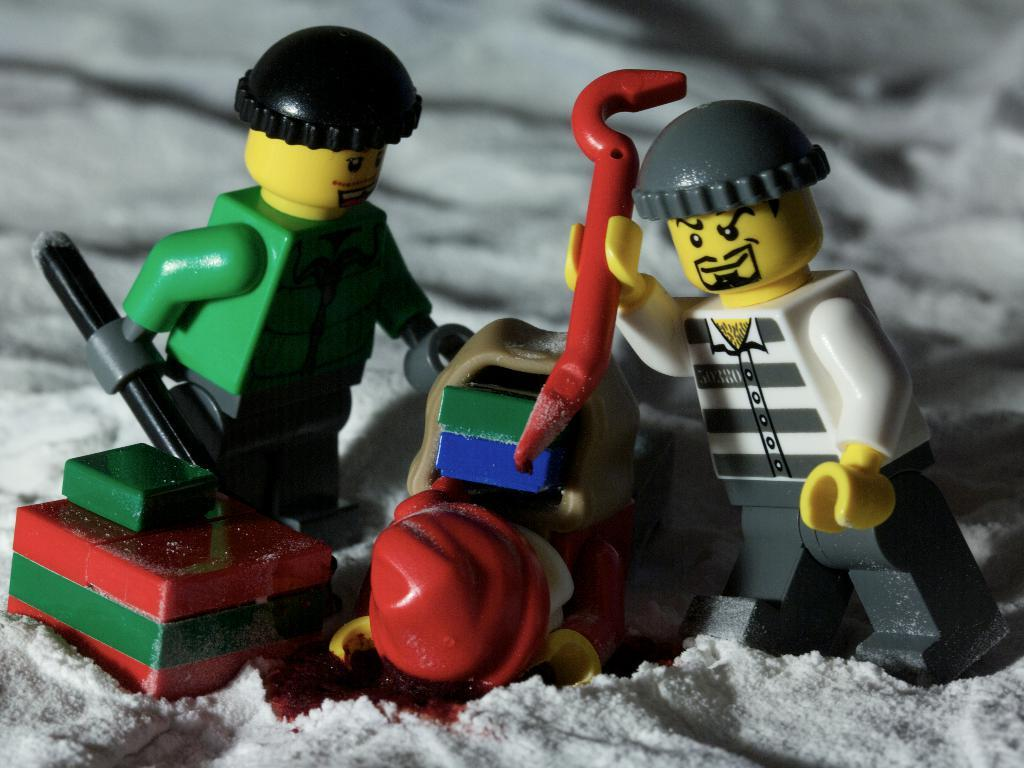What objects can be seen in the image? There are toys in the image. How are the toys positioned in the image? The toys are standing on the ground. What is covering the ground in the image? The ground is covered with snow. What are the toys holding in their hands? The toys are holding rods in their hands. What type of coat is the cheese wearing in the image? There is no cheese or coat present in the image. 